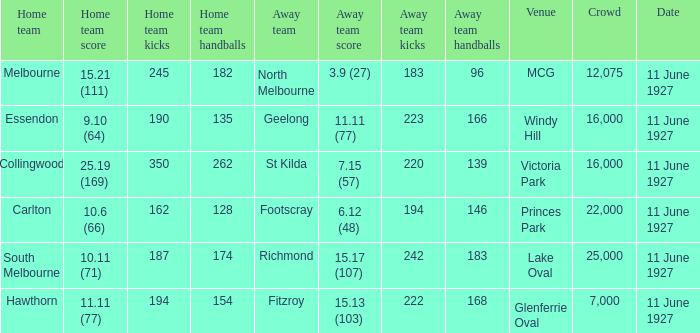How many people were present in a total of every crowd at the MCG venue? 12075.0. 